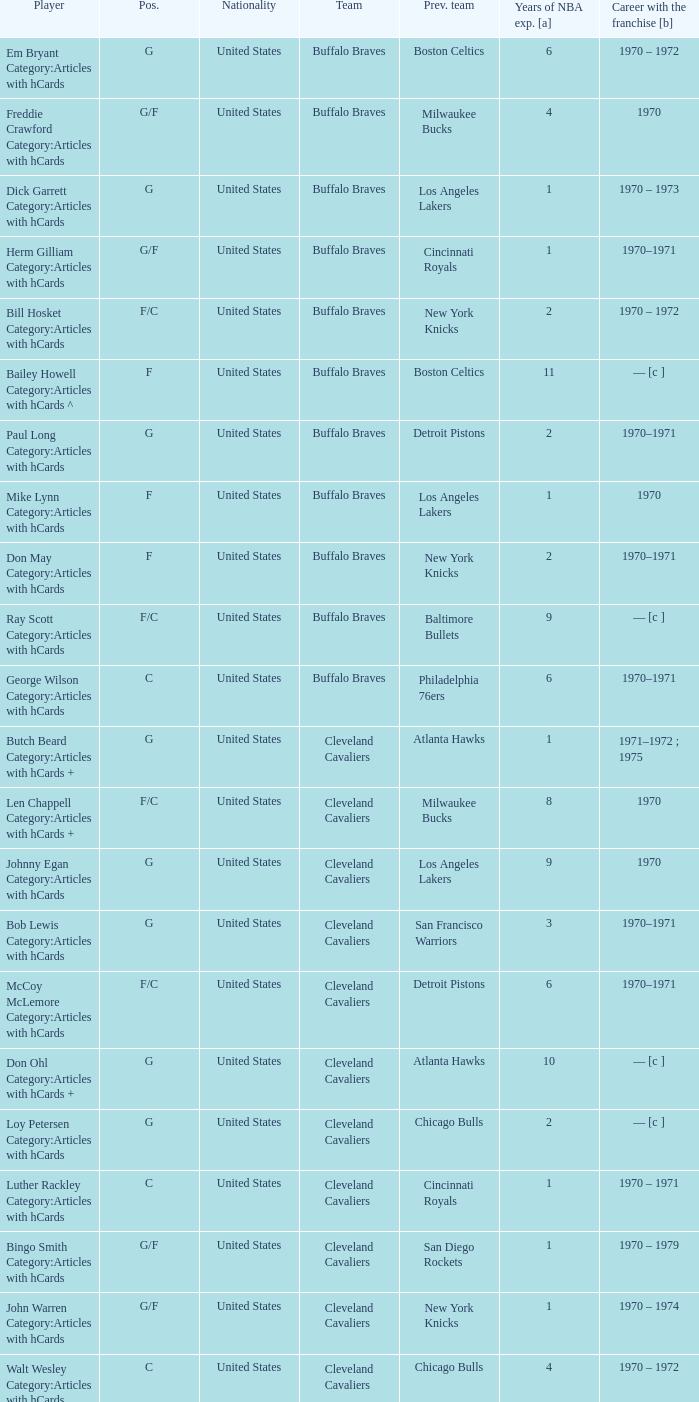Who is the player with 7 years of NBA experience? Larry Siegfried Category:Articles with hCards. 